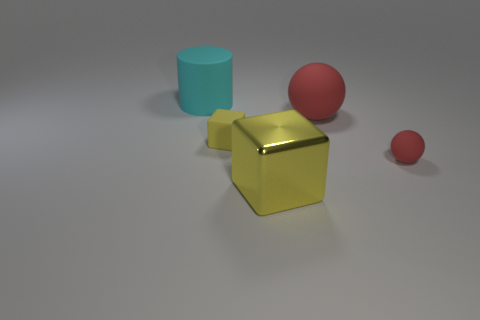Can you describe the lighting in the scene and how it affects the appearance of the objects? The image features soft and diffuse lighting that casts subtle shadows on the surface beneath the objects. This gentle illumination helps to bring out the textures and colors of the objects without creating harsh reflections or strong contrasts. 